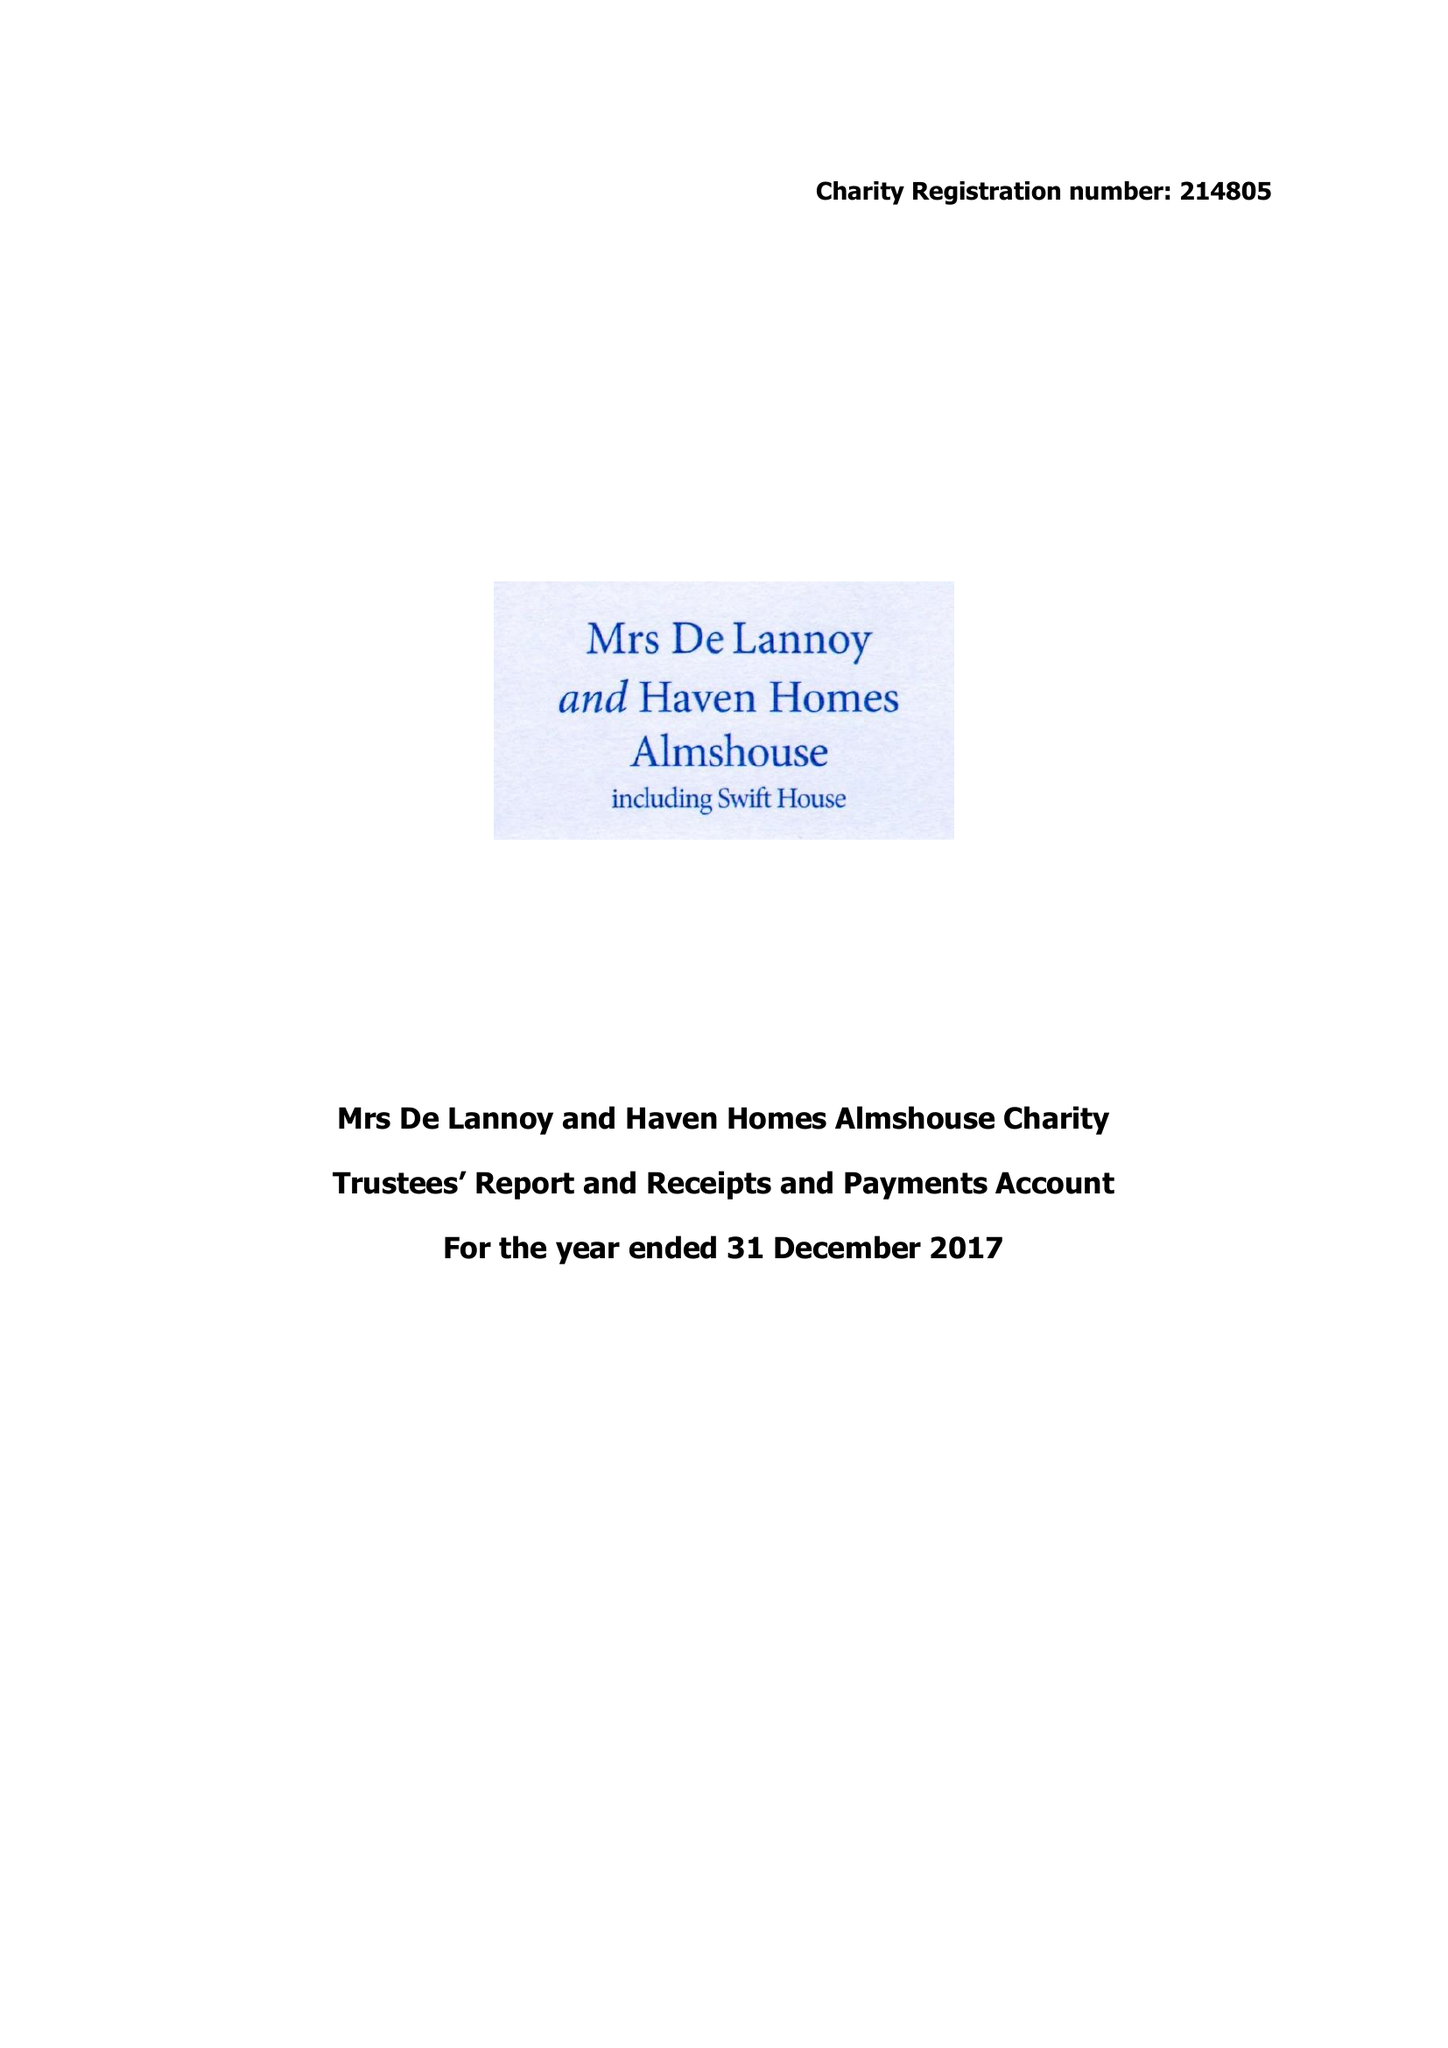What is the value for the charity_name?
Answer the question using a single word or phrase. Mrs De Lannoy and Haven Homes Almshouse Charity 